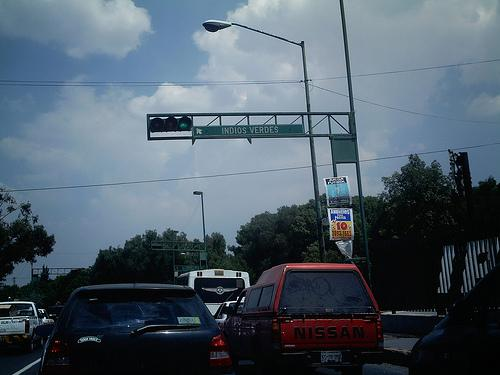Question: where was this photo taken?
Choices:
A. On the street.
B. On the beach.
C. On a ski slope.
D. In the yard.
Answer with the letter. Answer: A Question: what is present?
Choices:
A. Buses.
B. Cars.
C. Trains.
D. Planes.
Answer with the letter. Answer: B Question: how is the photo?
Choices:
A. Blurry.
B. Clear.
C. Over exposed.
D. Burned.
Answer with the letter. Answer: B Question: what are they on?
Choices:
A. The sidewalk.
B. A road.
C. The grass.
D. The railroad.
Answer with the letter. Answer: B 